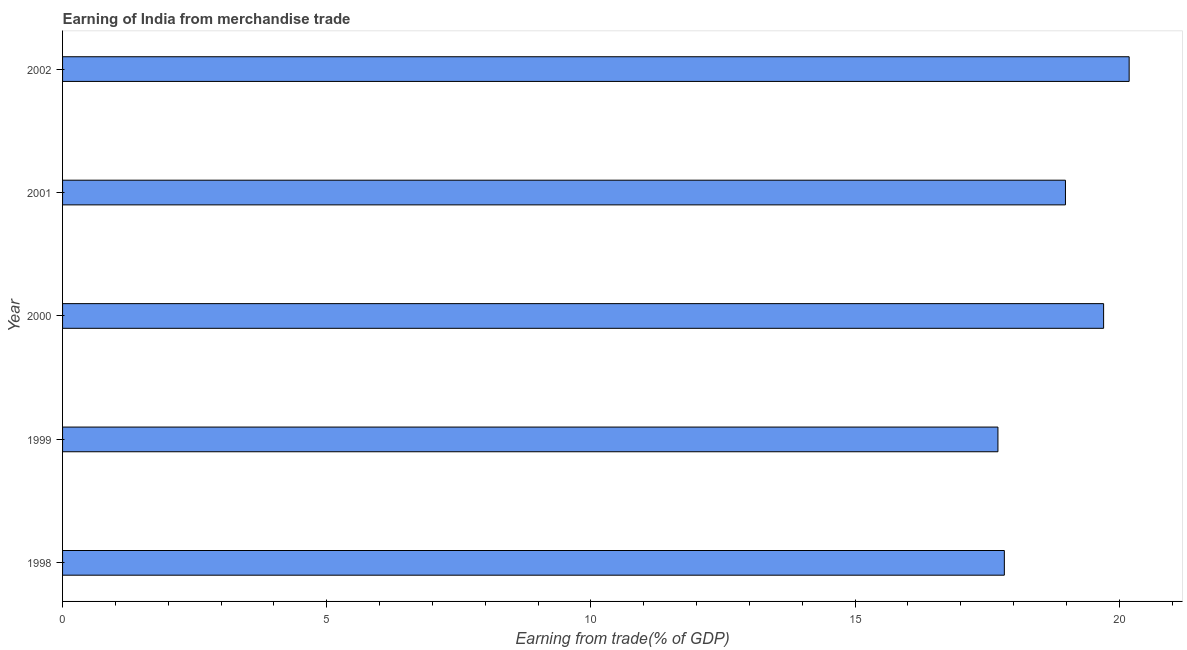Does the graph contain any zero values?
Your answer should be very brief. No. What is the title of the graph?
Provide a succinct answer. Earning of India from merchandise trade. What is the label or title of the X-axis?
Ensure brevity in your answer.  Earning from trade(% of GDP). What is the label or title of the Y-axis?
Your response must be concise. Year. What is the earning from merchandise trade in 2002?
Your answer should be very brief. 20.19. Across all years, what is the maximum earning from merchandise trade?
Provide a succinct answer. 20.19. Across all years, what is the minimum earning from merchandise trade?
Ensure brevity in your answer.  17.7. What is the sum of the earning from merchandise trade?
Offer a terse response. 94.39. What is the difference between the earning from merchandise trade in 1999 and 2002?
Ensure brevity in your answer.  -2.48. What is the average earning from merchandise trade per year?
Your response must be concise. 18.88. What is the median earning from merchandise trade?
Offer a very short reply. 18.98. In how many years, is the earning from merchandise trade greater than 6 %?
Offer a terse response. 5. Do a majority of the years between 2002 and 1998 (inclusive) have earning from merchandise trade greater than 6 %?
Offer a terse response. Yes. What is the ratio of the earning from merchandise trade in 1998 to that in 2001?
Ensure brevity in your answer.  0.94. Is the earning from merchandise trade in 1998 less than that in 2001?
Your answer should be very brief. Yes. Is the difference between the earning from merchandise trade in 1998 and 2001 greater than the difference between any two years?
Make the answer very short. No. What is the difference between the highest and the second highest earning from merchandise trade?
Offer a terse response. 0.48. What is the difference between the highest and the lowest earning from merchandise trade?
Your response must be concise. 2.48. In how many years, is the earning from merchandise trade greater than the average earning from merchandise trade taken over all years?
Offer a terse response. 3. How many bars are there?
Offer a very short reply. 5. Are all the bars in the graph horizontal?
Offer a very short reply. Yes. What is the difference between two consecutive major ticks on the X-axis?
Make the answer very short. 5. What is the Earning from trade(% of GDP) in 1998?
Give a very brief answer. 17.82. What is the Earning from trade(% of GDP) in 1999?
Your answer should be compact. 17.7. What is the Earning from trade(% of GDP) of 2000?
Keep it short and to the point. 19.7. What is the Earning from trade(% of GDP) of 2001?
Your response must be concise. 18.98. What is the Earning from trade(% of GDP) in 2002?
Provide a short and direct response. 20.19. What is the difference between the Earning from trade(% of GDP) in 1998 and 1999?
Your answer should be very brief. 0.12. What is the difference between the Earning from trade(% of GDP) in 1998 and 2000?
Provide a succinct answer. -1.88. What is the difference between the Earning from trade(% of GDP) in 1998 and 2001?
Ensure brevity in your answer.  -1.16. What is the difference between the Earning from trade(% of GDP) in 1998 and 2002?
Provide a succinct answer. -2.36. What is the difference between the Earning from trade(% of GDP) in 1999 and 2000?
Make the answer very short. -2. What is the difference between the Earning from trade(% of GDP) in 1999 and 2001?
Provide a succinct answer. -1.28. What is the difference between the Earning from trade(% of GDP) in 1999 and 2002?
Give a very brief answer. -2.48. What is the difference between the Earning from trade(% of GDP) in 2000 and 2001?
Provide a succinct answer. 0.72. What is the difference between the Earning from trade(% of GDP) in 2000 and 2002?
Your answer should be compact. -0.48. What is the difference between the Earning from trade(% of GDP) in 2001 and 2002?
Offer a terse response. -1.21. What is the ratio of the Earning from trade(% of GDP) in 1998 to that in 2000?
Provide a short and direct response. 0.91. What is the ratio of the Earning from trade(% of GDP) in 1998 to that in 2001?
Keep it short and to the point. 0.94. What is the ratio of the Earning from trade(% of GDP) in 1998 to that in 2002?
Your answer should be very brief. 0.88. What is the ratio of the Earning from trade(% of GDP) in 1999 to that in 2000?
Give a very brief answer. 0.9. What is the ratio of the Earning from trade(% of GDP) in 1999 to that in 2001?
Provide a succinct answer. 0.93. What is the ratio of the Earning from trade(% of GDP) in 1999 to that in 2002?
Your answer should be very brief. 0.88. What is the ratio of the Earning from trade(% of GDP) in 2000 to that in 2001?
Make the answer very short. 1.04. What is the ratio of the Earning from trade(% of GDP) in 2000 to that in 2002?
Give a very brief answer. 0.98. 